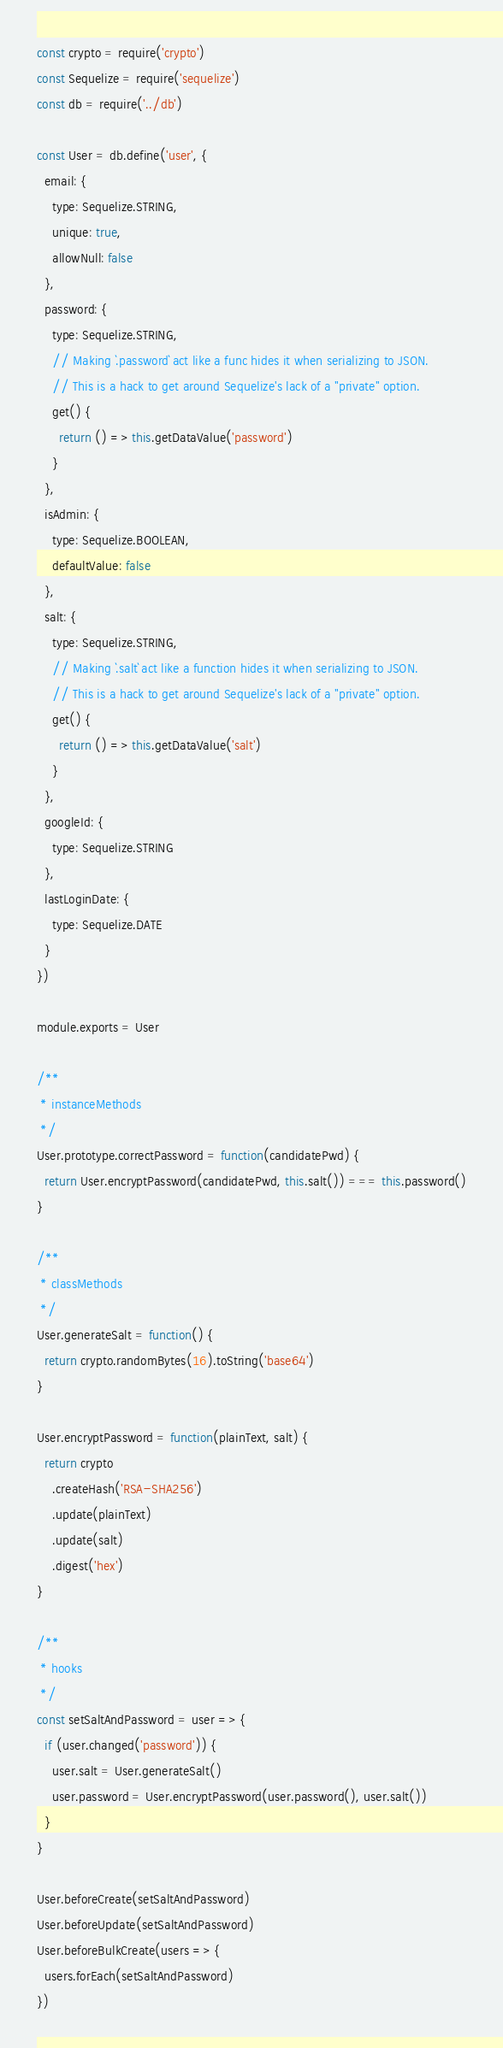<code> <loc_0><loc_0><loc_500><loc_500><_JavaScript_>const crypto = require('crypto')
const Sequelize = require('sequelize')
const db = require('../db')

const User = db.define('user', {
  email: {
    type: Sequelize.STRING,
    unique: true,
    allowNull: false
  },
  password: {
    type: Sequelize.STRING,
    // Making `.password` act like a func hides it when serializing to JSON.
    // This is a hack to get around Sequelize's lack of a "private" option.
    get() {
      return () => this.getDataValue('password')
    }
  },
  isAdmin: {
    type: Sequelize.BOOLEAN,
    defaultValue: false
  },
  salt: {
    type: Sequelize.STRING,
    // Making `.salt` act like a function hides it when serializing to JSON.
    // This is a hack to get around Sequelize's lack of a "private" option.
    get() {
      return () => this.getDataValue('salt')
    }
  },
  googleId: {
    type: Sequelize.STRING
  },
  lastLoginDate: {
    type: Sequelize.DATE
  }
})

module.exports = User

/**
 * instanceMethods
 */
User.prototype.correctPassword = function(candidatePwd) {
  return User.encryptPassword(candidatePwd, this.salt()) === this.password()
}

/**
 * classMethods
 */
User.generateSalt = function() {
  return crypto.randomBytes(16).toString('base64')
}

User.encryptPassword = function(plainText, salt) {
  return crypto
    .createHash('RSA-SHA256')
    .update(plainText)
    .update(salt)
    .digest('hex')
}

/**
 * hooks
 */
const setSaltAndPassword = user => {
  if (user.changed('password')) {
    user.salt = User.generateSalt()
    user.password = User.encryptPassword(user.password(), user.salt())
  }
}

User.beforeCreate(setSaltAndPassword)
User.beforeUpdate(setSaltAndPassword)
User.beforeBulkCreate(users => {
  users.forEach(setSaltAndPassword)
})
</code> 